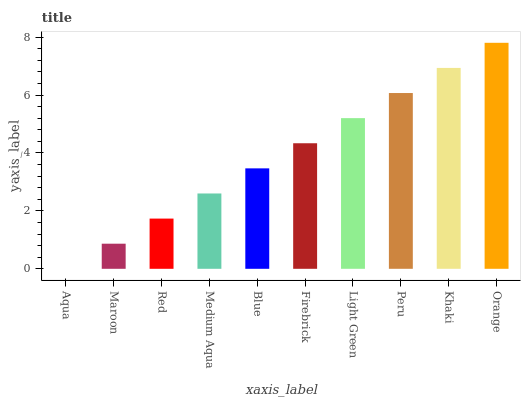Is Aqua the minimum?
Answer yes or no. Yes. Is Orange the maximum?
Answer yes or no. Yes. Is Maroon the minimum?
Answer yes or no. No. Is Maroon the maximum?
Answer yes or no. No. Is Maroon greater than Aqua?
Answer yes or no. Yes. Is Aqua less than Maroon?
Answer yes or no. Yes. Is Aqua greater than Maroon?
Answer yes or no. No. Is Maroon less than Aqua?
Answer yes or no. No. Is Firebrick the high median?
Answer yes or no. Yes. Is Blue the low median?
Answer yes or no. Yes. Is Peru the high median?
Answer yes or no. No. Is Red the low median?
Answer yes or no. No. 